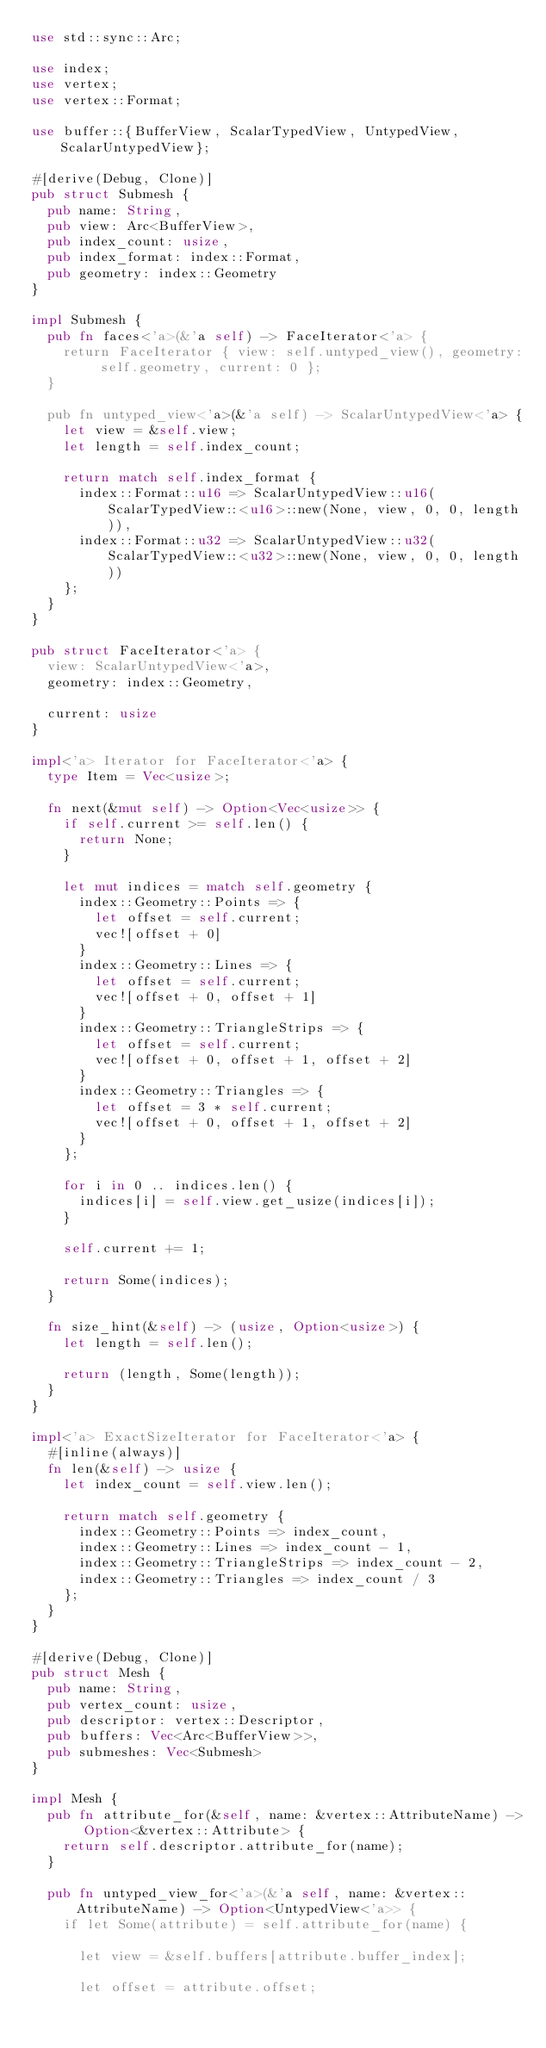Convert code to text. <code><loc_0><loc_0><loc_500><loc_500><_Rust_>use std::sync::Arc;

use index;
use vertex;
use vertex::Format;

use buffer::{BufferView, ScalarTypedView, UntypedView, ScalarUntypedView};

#[derive(Debug, Clone)]
pub struct Submesh {
  pub name: String,
  pub view: Arc<BufferView>,
  pub index_count: usize,
  pub index_format: index::Format,
  pub geometry: index::Geometry
}

impl Submesh {
  pub fn faces<'a>(&'a self) -> FaceIterator<'a> {
    return FaceIterator { view: self.untyped_view(), geometry: self.geometry, current: 0 };
  }
  
  pub fn untyped_view<'a>(&'a self) -> ScalarUntypedView<'a> {
    let view = &self.view;
    let length = self.index_count;

    return match self.index_format {
      index::Format::u16 => ScalarUntypedView::u16(ScalarTypedView::<u16>::new(None, view, 0, 0, length)),
      index::Format::u32 => ScalarUntypedView::u32(ScalarTypedView::<u32>::new(None, view, 0, 0, length))
    };
  }
}

pub struct FaceIterator<'a> {
  view: ScalarUntypedView<'a>,
  geometry: index::Geometry,

  current: usize
}

impl<'a> Iterator for FaceIterator<'a> {
  type Item = Vec<usize>;

  fn next(&mut self) -> Option<Vec<usize>> {
    if self.current >= self.len() {
      return None;
    }

    let mut indices = match self.geometry {
      index::Geometry::Points => {
        let offset = self.current;
        vec![offset + 0]
      }
      index::Geometry::Lines => {
        let offset = self.current;
        vec![offset + 0, offset + 1]
      }
      index::Geometry::TriangleStrips => {
        let offset = self.current;
        vec![offset + 0, offset + 1, offset + 2]
      }
      index::Geometry::Triangles => {
        let offset = 3 * self.current;
        vec![offset + 0, offset + 1, offset + 2]
      }
    };

    for i in 0 .. indices.len() {
      indices[i] = self.view.get_usize(indices[i]);
    }

    self.current += 1;

    return Some(indices);
  }

  fn size_hint(&self) -> (usize, Option<usize>) {
    let length = self.len();

    return (length, Some(length));
  }
}

impl<'a> ExactSizeIterator for FaceIterator<'a> {
  #[inline(always)]
  fn len(&self) -> usize {
    let index_count = self.view.len();

    return match self.geometry {
      index::Geometry::Points => index_count,
      index::Geometry::Lines => index_count - 1,
      index::Geometry::TriangleStrips => index_count - 2,
      index::Geometry::Triangles => index_count / 3
    };
  }
}

#[derive(Debug, Clone)]
pub struct Mesh {
  pub name: String,
  pub vertex_count: usize,
  pub descriptor: vertex::Descriptor,
  pub buffers: Vec<Arc<BufferView>>,
  pub submeshes: Vec<Submesh>
}

impl Mesh {
  pub fn attribute_for(&self, name: &vertex::AttributeName) -> Option<&vertex::Attribute> {
    return self.descriptor.attribute_for(name);
  }

  pub fn untyped_view_for<'a>(&'a self, name: &vertex::AttributeName) -> Option<UntypedView<'a>> {
    if let Some(attribute) = self.attribute_for(name) {

      let view = &self.buffers[attribute.buffer_index];

      let offset = attribute.offset;</code> 